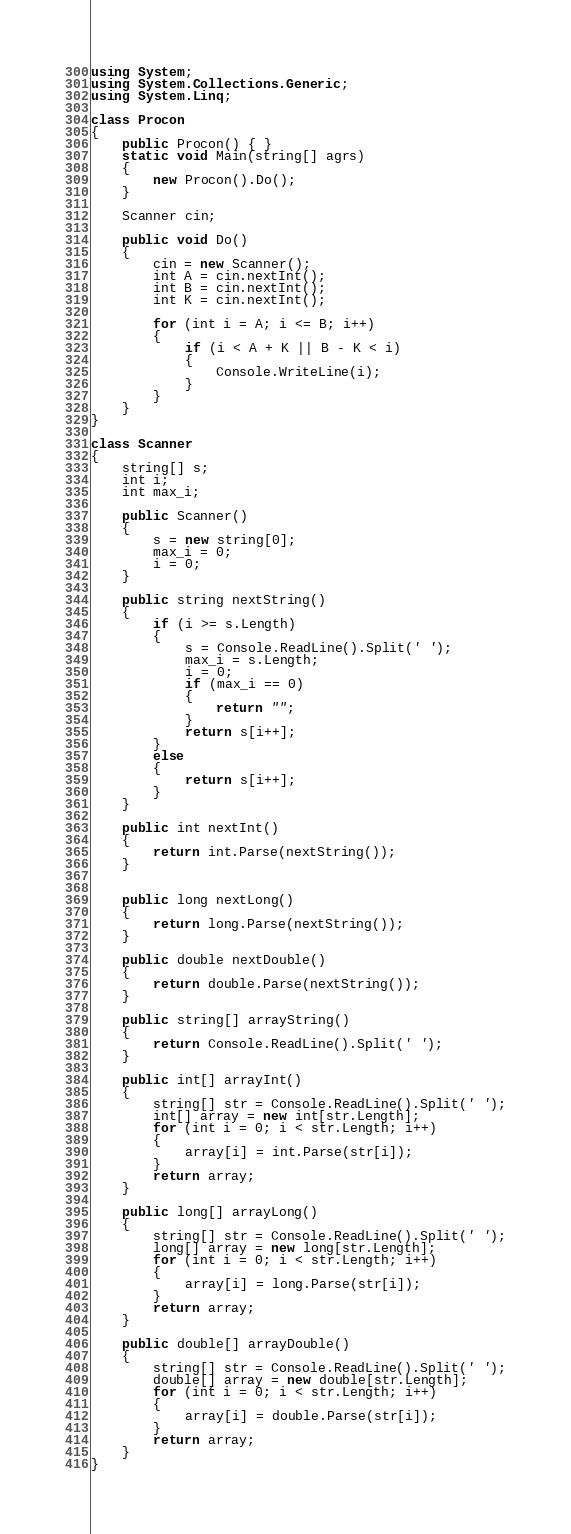Convert code to text. <code><loc_0><loc_0><loc_500><loc_500><_C#_>using System;
using System.Collections.Generic;
using System.Linq;

class Procon
{
    public Procon() { }
    static void Main(string[] agrs)
    {
        new Procon().Do();
    }

    Scanner cin;

    public void Do()
    {
        cin = new Scanner();
        int A = cin.nextInt();
        int B = cin.nextInt();
        int K = cin.nextInt();

        for (int i = A; i <= B; i++)
        {
            if (i < A + K || B - K < i)
            {
                Console.WriteLine(i);
            }
        }
    }
}

class Scanner
{
    string[] s;
    int i;
    int max_i;

    public Scanner()
    {
        s = new string[0];
        max_i = 0;
        i = 0;
    }

    public string nextString()
    {
        if (i >= s.Length)
        {
            s = Console.ReadLine().Split(' ');
            max_i = s.Length;
            i = 0;
            if (max_i == 0)
            {
                return "";
            }
            return s[i++];
        }
        else
        {
            return s[i++];
        }
    }

    public int nextInt()
    {
        return int.Parse(nextString());
    }


    public long nextLong()
    {
        return long.Parse(nextString());
    }

    public double nextDouble()
    {
        return double.Parse(nextString());
    }

    public string[] arrayString()
    {
        return Console.ReadLine().Split(' ');
    }

    public int[] arrayInt()
    {
        string[] str = Console.ReadLine().Split(' ');
        int[] array = new int[str.Length];
        for (int i = 0; i < str.Length; i++)
        {
            array[i] = int.Parse(str[i]);
        }
        return array;
    }

    public long[] arrayLong()
    {
        string[] str = Console.ReadLine().Split(' ');
        long[] array = new long[str.Length];
        for (int i = 0; i < str.Length; i++)
        {
            array[i] = long.Parse(str[i]);
        }
        return array;
    }

    public double[] arrayDouble()
    {
        string[] str = Console.ReadLine().Split(' ');
        double[] array = new double[str.Length];
        for (int i = 0; i < str.Length; i++)
        {
            array[i] = double.Parse(str[i]);
        }
        return array;
    }
}</code> 